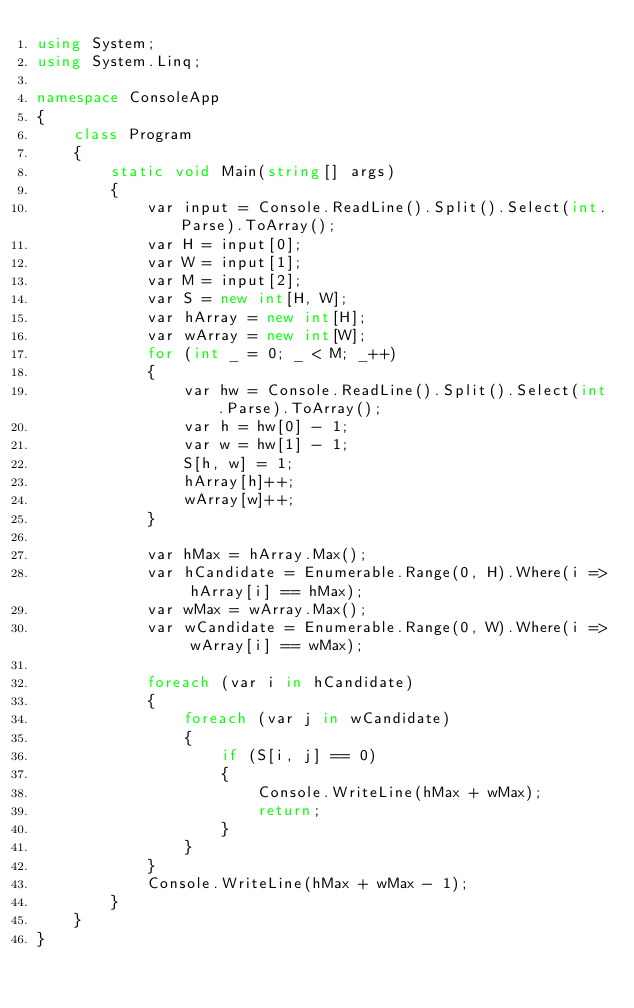Convert code to text. <code><loc_0><loc_0><loc_500><loc_500><_C#_>using System;
using System.Linq;

namespace ConsoleApp
{
    class Program
    {
        static void Main(string[] args)
        {
            var input = Console.ReadLine().Split().Select(int.Parse).ToArray();
            var H = input[0];
            var W = input[1];
            var M = input[2];
            var S = new int[H, W];
            var hArray = new int[H];
            var wArray = new int[W];
            for (int _ = 0; _ < M; _++)
            {
                var hw = Console.ReadLine().Split().Select(int.Parse).ToArray();
                var h = hw[0] - 1;
                var w = hw[1] - 1;
                S[h, w] = 1;
                hArray[h]++;
                wArray[w]++;
            }

            var hMax = hArray.Max();
            var hCandidate = Enumerable.Range(0, H).Where(i => hArray[i] == hMax);
            var wMax = wArray.Max();
            var wCandidate = Enumerable.Range(0, W).Where(i => wArray[i] == wMax);

            foreach (var i in hCandidate)
            {
                foreach (var j in wCandidate)
                {
                    if (S[i, j] == 0)
                    {
                        Console.WriteLine(hMax + wMax);
                        return;
                    }
                }
            }
            Console.WriteLine(hMax + wMax - 1);
        }
    }
}
</code> 